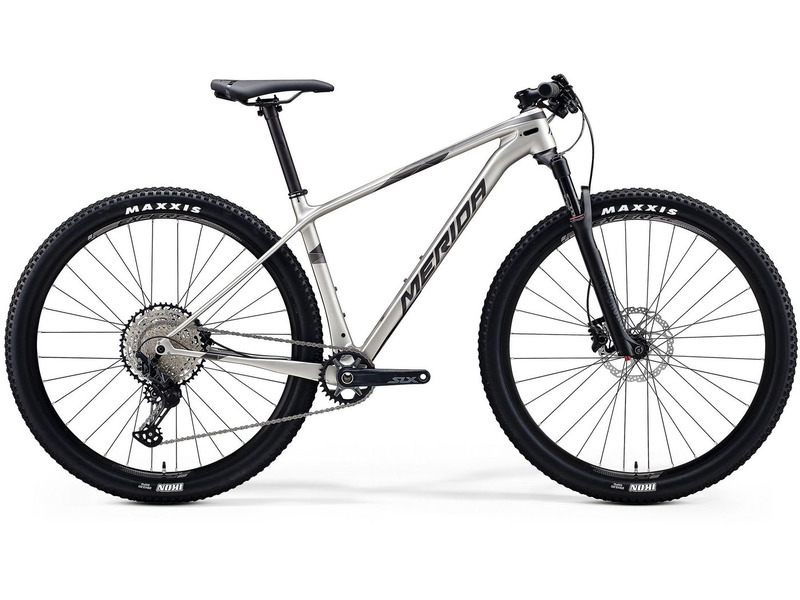Considering the features of this mountain bike, such as the tire tread pattern, suspension system, and absence of a front derailleur, for what type of riding conditions and activities is this bike specifically designed? Observing the mountain bike in the image, it is evident that this model is outfitted with knobby MAXXIS tires, which are known for their excellent grip on loose or uneven surfaces. Additionally, the bike features a front suspension fork designed to absorb shocks from rough terrain, making it ideal for tackling rugged trails. The single chainring setup, which forgoes a front derailleur, simplifies the drivetrain and reduces overall weight, which can be particularly advantageous for climbing and technical trail navigation. Therefore, this bike is meticulously designed for off-road cycling, notably suited for cross-country and trail riding. These activities require a lightweight and agile bike that excels in varied terrains, providing the rider with stability, control, and ease of handling in demanding conditions. 